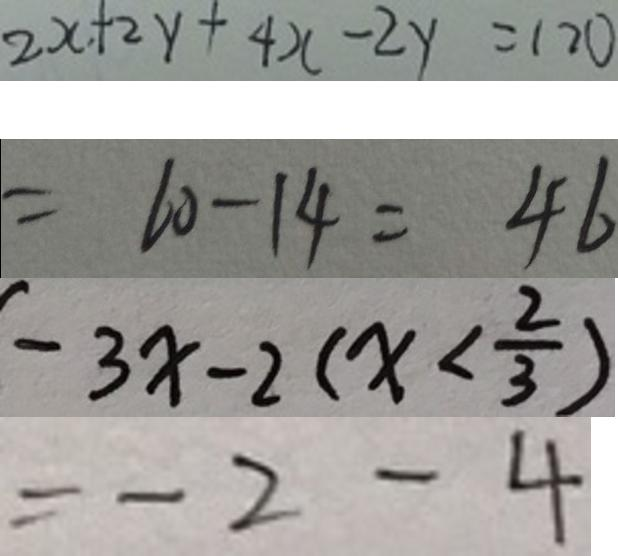<formula> <loc_0><loc_0><loc_500><loc_500>2 x + 2 y + 4 x - 2 y = 1 2 0 
 = 6 0 - 1 4 = 4 6 
 - 3 x - 2 ( x < \frac { 2 } { 3 } ) 
 = - 2 - 4</formula> 